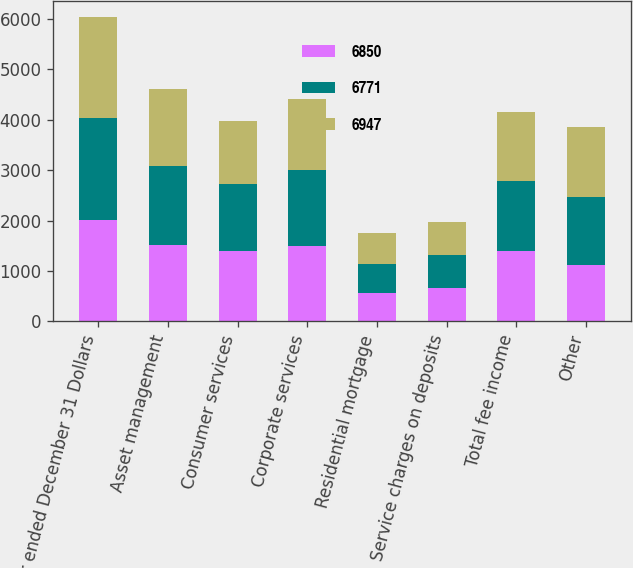Convert chart. <chart><loc_0><loc_0><loc_500><loc_500><stacked_bar_chart><ecel><fcel>Year ended December 31 Dollars<fcel>Asset management<fcel>Consumer services<fcel>Corporate services<fcel>Residential mortgage<fcel>Service charges on deposits<fcel>Total fee income<fcel>Other<nl><fcel>6850<fcel>2016<fcel>1521<fcel>1388<fcel>1504<fcel>567<fcel>667<fcel>1388<fcel>1124<nl><fcel>6771<fcel>2015<fcel>1567<fcel>1335<fcel>1491<fcel>566<fcel>651<fcel>1388<fcel>1337<nl><fcel>6947<fcel>2014<fcel>1513<fcel>1254<fcel>1415<fcel>618<fcel>662<fcel>1388<fcel>1388<nl></chart> 